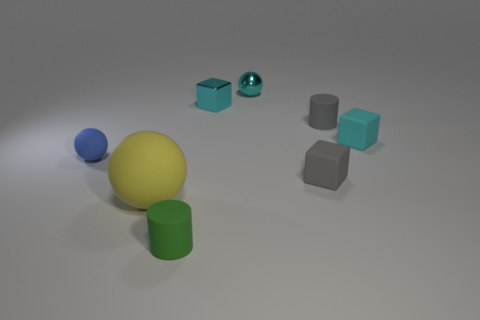Is the shape of the small gray object that is in front of the tiny blue object the same as the tiny thing that is to the left of the green matte cylinder?
Offer a terse response. No. What number of things are blue rubber objects or tiny red blocks?
Offer a very short reply. 1. There is another metal object that is the same shape as the small blue object; what is its size?
Your answer should be compact. Small. Are there more green cylinders that are behind the cyan rubber object than gray cylinders?
Your response must be concise. No. Are the gray cube and the yellow object made of the same material?
Make the answer very short. Yes. What number of things are either cyan cubes to the left of the small cyan metal ball or rubber blocks that are on the right side of the tiny gray matte cylinder?
Your response must be concise. 2. What is the color of the small matte object that is the same shape as the big thing?
Your answer should be very brief. Blue. What number of rubber cubes are the same color as the large thing?
Provide a short and direct response. 0. Do the big matte sphere and the tiny metallic ball have the same color?
Your answer should be compact. No. How many objects are either spheres behind the tiny gray cylinder or gray cubes?
Offer a terse response. 2. 